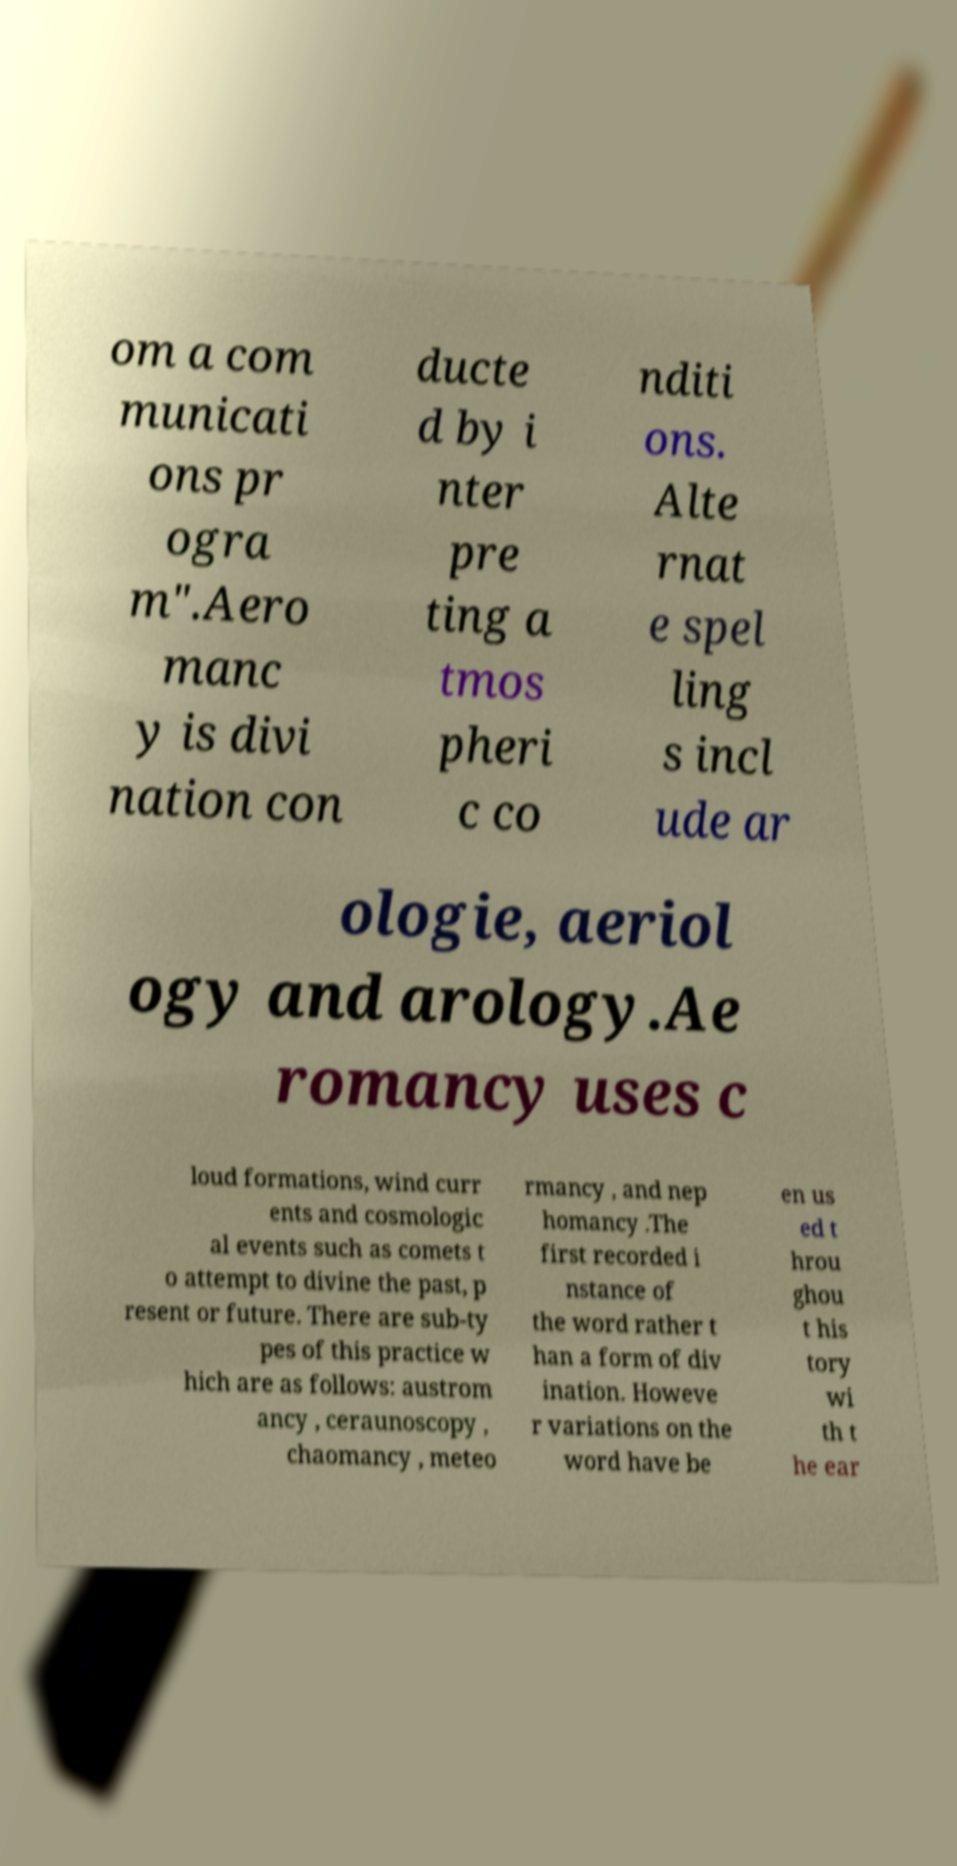For documentation purposes, I need the text within this image transcribed. Could you provide that? om a com municati ons pr ogra m".Aero manc y is divi nation con ducte d by i nter pre ting a tmos pheri c co nditi ons. Alte rnat e spel ling s incl ude ar ologie, aeriol ogy and arology.Ae romancy uses c loud formations, wind curr ents and cosmologic al events such as comets t o attempt to divine the past, p resent or future. There are sub-ty pes of this practice w hich are as follows: austrom ancy , ceraunoscopy , chaomancy , meteo rmancy , and nep homancy .The first recorded i nstance of the word rather t han a form of div ination. Howeve r variations on the word have be en us ed t hrou ghou t his tory wi th t he ear 